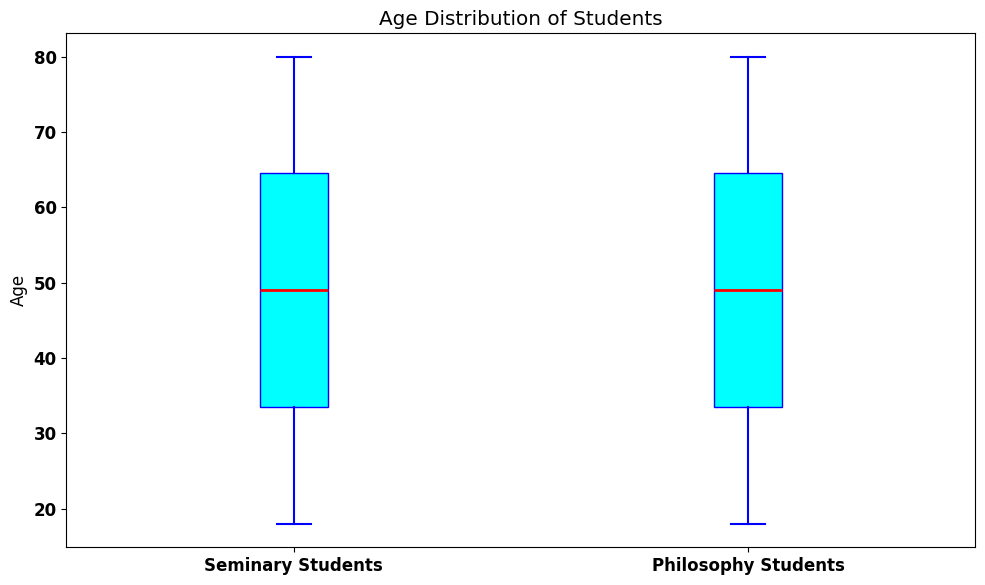What is the median age of seminary students? To determine the median age, locate the middle value of the sorted seminary ages. There are 63 students, and the median is the age of the 32nd student in the sorted list.
Answer: 49 What is the range of ages for philosophy students? The range is calculated by subtracting the minimum age from the maximum age. The minimum age is 18 and the maximum age is 80. Therefore, the range is 80 - 18.
Answer: 62 How does the median age of philosophy students compare to that of seminary students? Compare the medians from both groups. The median age of seminary students is 49, and the median age of philosophy students is also 49. Hence, they are equal.
Answer: Equal Which group has a higher interquartile range (IQR)? The IQR is found by subtracting the first quartile (Q1) from the third quartile (Q3). Visually compare the box lengths (the boxes represent the IQR) for the two groups. The lengths appear comparable, so the IQRs are likely similar.
Answer: Similar What is the color of the boxes representing the age distributions in the plot? The color of the boxes can be identified directly from the visual. The plot shows cyan-colored boxes.
Answer: Cyan Identify the age range covered by the whiskers of seminary students. The whiskers extend to the smallest and largest data points within 1.5 times the IQR from the Q1 and Q3 respectively. For seminary students, the range appears to be from 18 to 80.
Answer: 18 to 80 Are there any outliers in the age distributions of either group? Outliers are typically marked as individual points outside the whiskers. Visually examine the plot for any such points. There are no outliers for either group.
Answer: No Compare the maximum age of seminary students to that of philosophy students. Visually check the upper whisker endpoints for both groups. Both groups extend to the maximum age of 80.
Answer: Equal Between seminary and philosophy students, which group has a wider range of middle 50% ages? The range of the middle 50% is represented by the length of the box. By comparing the lengths, both boxes appear equally wide.
Answer: Similar 